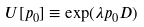Convert formula to latex. <formula><loc_0><loc_0><loc_500><loc_500>U [ p _ { 0 } ] \equiv \exp ( \lambda p _ { 0 } D )</formula> 